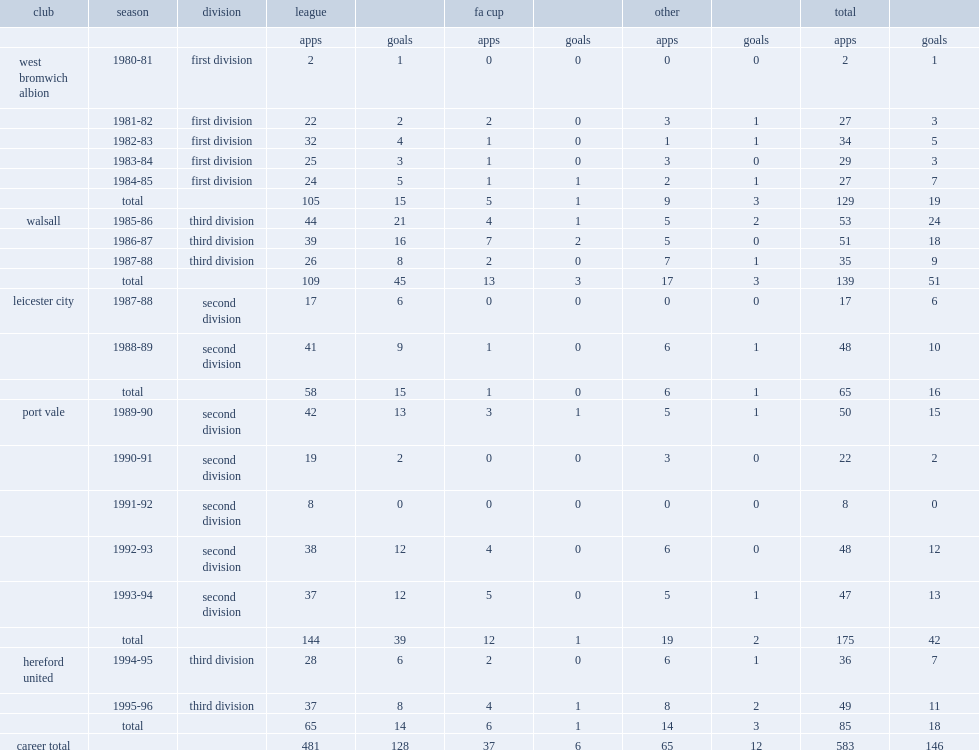Which club did cross play for in 1980-81? West bromwich albion. 